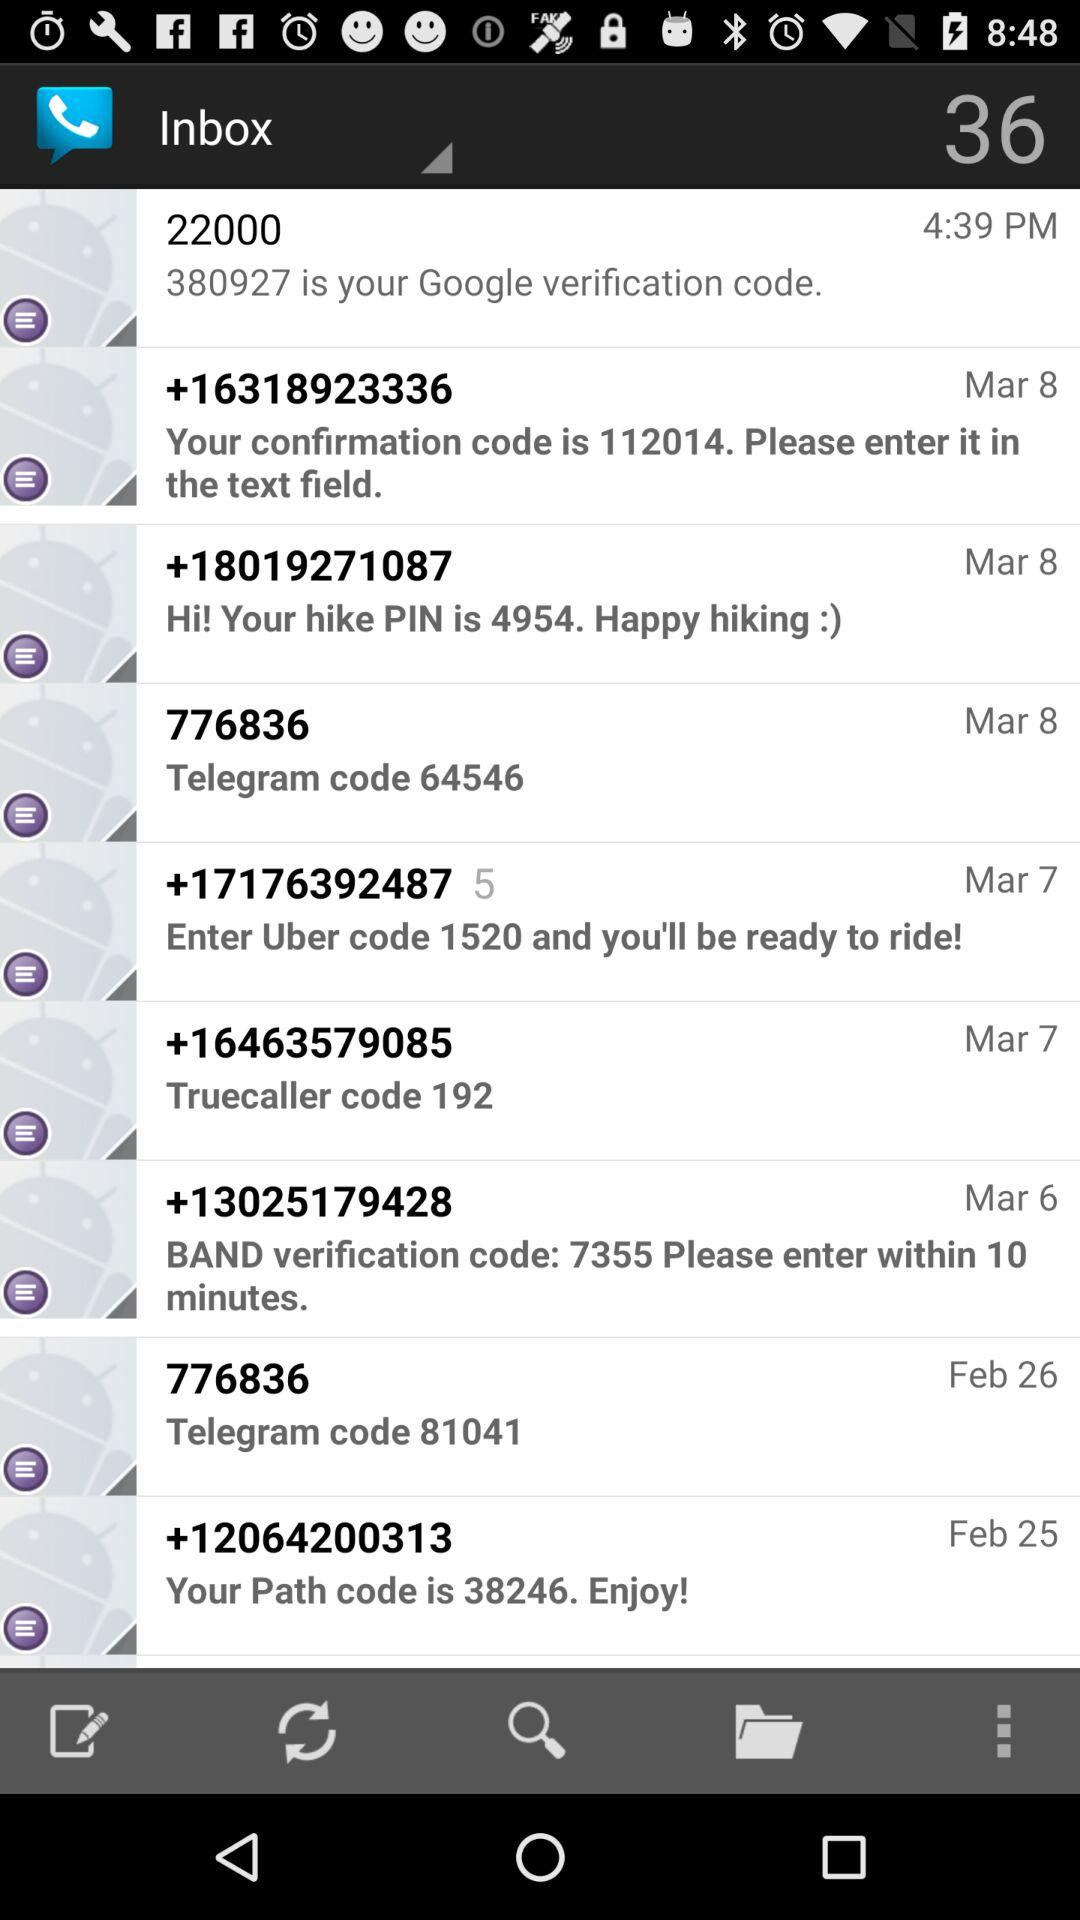What is the path code? The path code is 38246. 